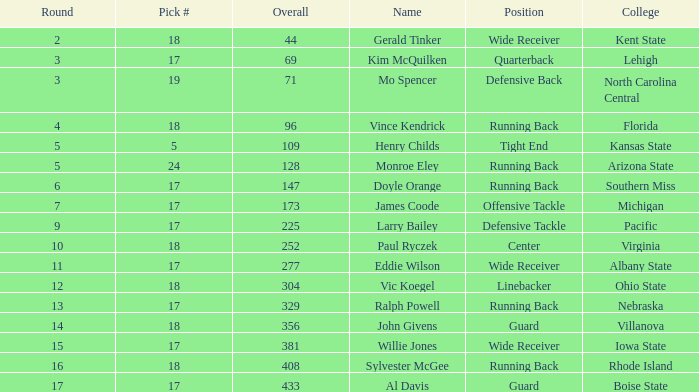Identify the complete number of rounds for kent state's wide receiver. 1.0. 